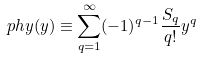<formula> <loc_0><loc_0><loc_500><loc_500>\ p h y ( y ) \equiv \sum _ { q = 1 } ^ { \infty } ( - 1 ) ^ { q - 1 } \frac { S _ { q } } { q ! } y ^ { q }</formula> 